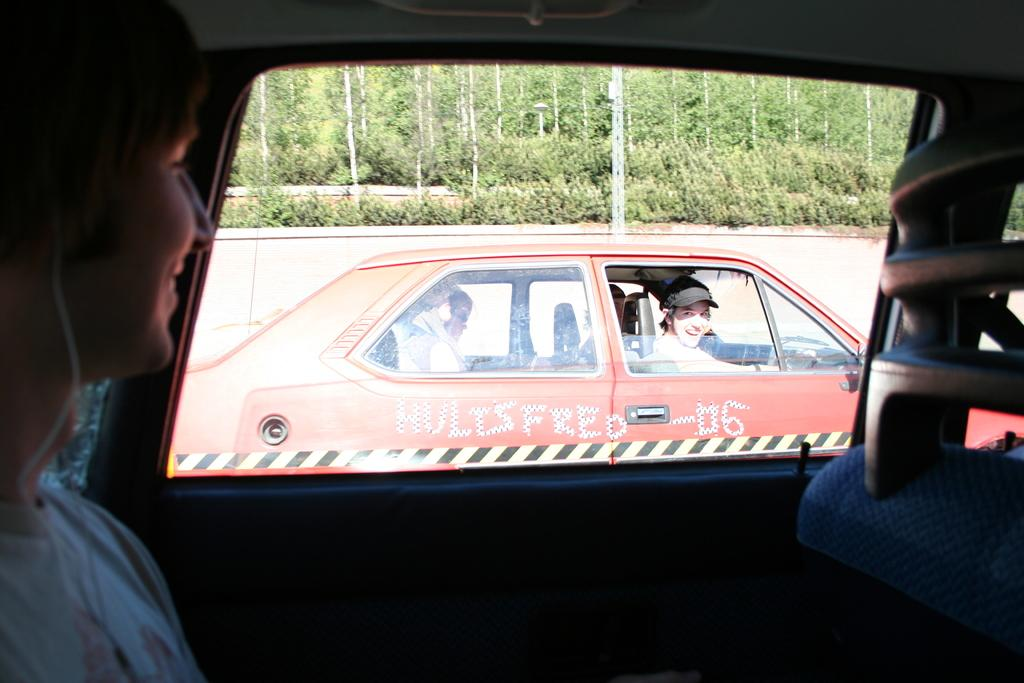How many people are in the image? There are two people in the image. What are the people doing in the image? Both people are smiling at each other. Where are the people located in the image? Both people are sitting in cars. What can be seen in the background of the image? There are trees visible in the background of the image. What time of day is it in the image, considering the afternoon? The provided facts do not mention the time of day, so we cannot determine if it is afternoon or not. --- Facts: 1. There is a cat in the image. 2. The cat is sitting on a chair. 3. The chair is in a room. 4. There is a window in the room. 5. The window has curtains. Absurd Topics: ocean, bicycle, dance Conversation: 